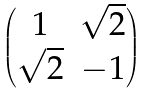<formula> <loc_0><loc_0><loc_500><loc_500>\begin{pmatrix} 1 & \sqrt { 2 } \\ \sqrt { 2 } & - 1 \end{pmatrix}</formula> 